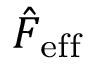<formula> <loc_0><loc_0><loc_500><loc_500>\hat { F } _ { e f f }</formula> 